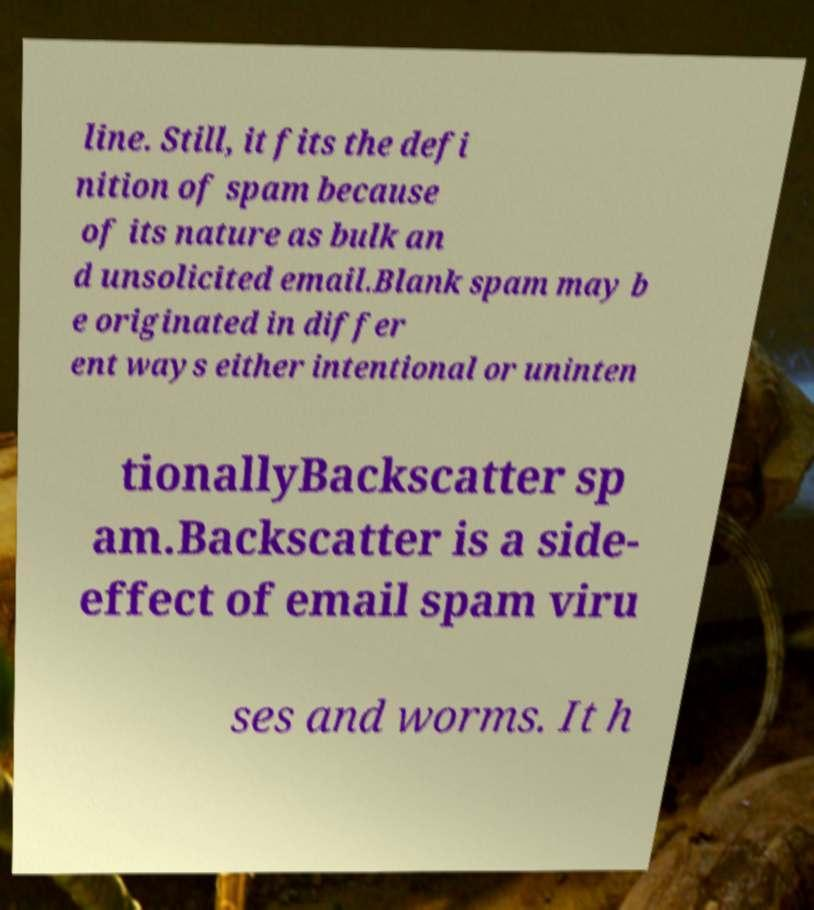Can you accurately transcribe the text from the provided image for me? line. Still, it fits the defi nition of spam because of its nature as bulk an d unsolicited email.Blank spam may b e originated in differ ent ways either intentional or uninten tionallyBackscatter sp am.Backscatter is a side- effect of email spam viru ses and worms. It h 